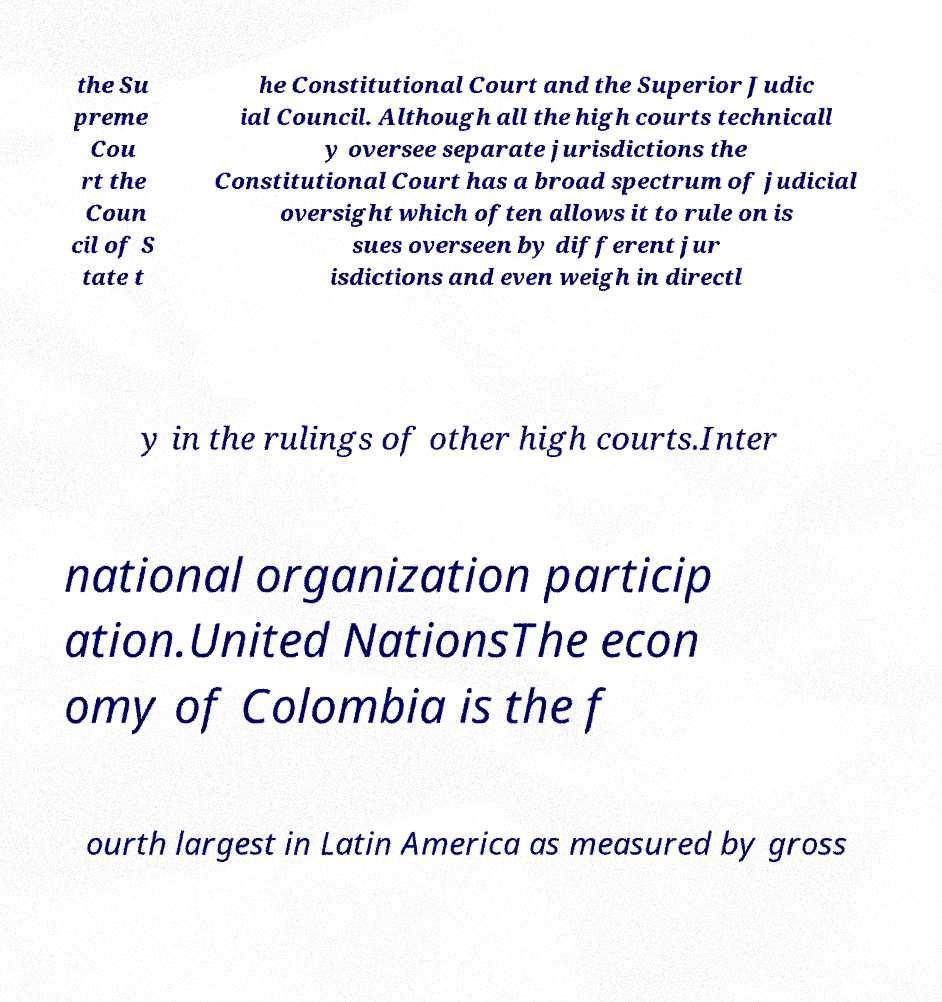Please identify and transcribe the text found in this image. the Su preme Cou rt the Coun cil of S tate t he Constitutional Court and the Superior Judic ial Council. Although all the high courts technicall y oversee separate jurisdictions the Constitutional Court has a broad spectrum of judicial oversight which often allows it to rule on is sues overseen by different jur isdictions and even weigh in directl y in the rulings of other high courts.Inter national organization particip ation.United NationsThe econ omy of Colombia is the f ourth largest in Latin America as measured by gross 